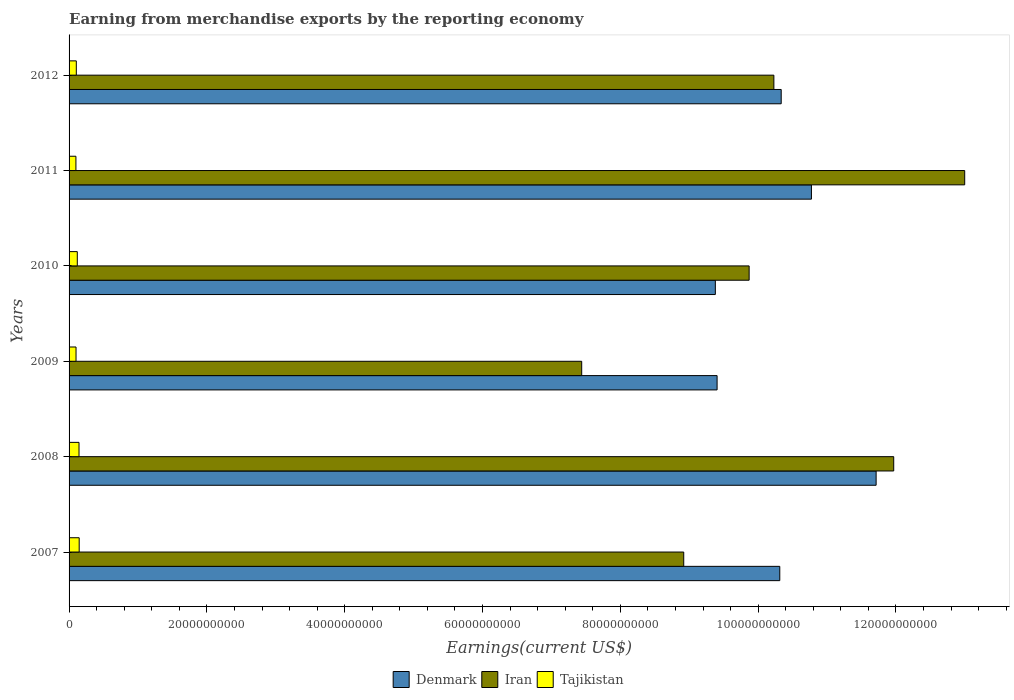How many different coloured bars are there?
Make the answer very short. 3. What is the label of the 5th group of bars from the top?
Offer a very short reply. 2008. What is the amount earned from merchandise exports in Iran in 2008?
Make the answer very short. 1.20e+11. Across all years, what is the maximum amount earned from merchandise exports in Denmark?
Provide a short and direct response. 1.17e+11. Across all years, what is the minimum amount earned from merchandise exports in Denmark?
Provide a succinct answer. 9.38e+1. In which year was the amount earned from merchandise exports in Tajikistan maximum?
Give a very brief answer. 2007. In which year was the amount earned from merchandise exports in Denmark minimum?
Give a very brief answer. 2010. What is the total amount earned from merchandise exports in Tajikistan in the graph?
Provide a succinct answer. 7.16e+09. What is the difference between the amount earned from merchandise exports in Denmark in 2008 and that in 2011?
Your answer should be very brief. 9.39e+09. What is the difference between the amount earned from merchandise exports in Tajikistan in 2011 and the amount earned from merchandise exports in Denmark in 2007?
Give a very brief answer. -1.02e+11. What is the average amount earned from merchandise exports in Iran per year?
Make the answer very short. 1.02e+11. In the year 2008, what is the difference between the amount earned from merchandise exports in Tajikistan and amount earned from merchandise exports in Iran?
Your answer should be compact. -1.18e+11. What is the ratio of the amount earned from merchandise exports in Denmark in 2007 to that in 2010?
Make the answer very short. 1.1. Is the difference between the amount earned from merchandise exports in Tajikistan in 2008 and 2011 greater than the difference between the amount earned from merchandise exports in Iran in 2008 and 2011?
Make the answer very short. Yes. What is the difference between the highest and the second highest amount earned from merchandise exports in Denmark?
Your answer should be compact. 9.39e+09. What is the difference between the highest and the lowest amount earned from merchandise exports in Iran?
Make the answer very short. 5.56e+1. In how many years, is the amount earned from merchandise exports in Iran greater than the average amount earned from merchandise exports in Iran taken over all years?
Provide a short and direct response. 2. Is the sum of the amount earned from merchandise exports in Iran in 2010 and 2012 greater than the maximum amount earned from merchandise exports in Denmark across all years?
Keep it short and to the point. Yes. What does the 2nd bar from the top in 2008 represents?
Your answer should be very brief. Iran. What does the 2nd bar from the bottom in 2008 represents?
Keep it short and to the point. Iran. How many bars are there?
Provide a short and direct response. 18. How many years are there in the graph?
Provide a succinct answer. 6. Does the graph contain any zero values?
Your answer should be compact. No. Does the graph contain grids?
Your answer should be compact. No. Where does the legend appear in the graph?
Give a very brief answer. Bottom center. How many legend labels are there?
Give a very brief answer. 3. What is the title of the graph?
Offer a very short reply. Earning from merchandise exports by the reporting economy. Does "World" appear as one of the legend labels in the graph?
Offer a terse response. No. What is the label or title of the X-axis?
Your response must be concise. Earnings(current US$). What is the Earnings(current US$) in Denmark in 2007?
Keep it short and to the point. 1.03e+11. What is the Earnings(current US$) of Iran in 2007?
Your answer should be compact. 8.92e+1. What is the Earnings(current US$) in Tajikistan in 2007?
Offer a very short reply. 1.47e+09. What is the Earnings(current US$) of Denmark in 2008?
Your answer should be compact. 1.17e+11. What is the Earnings(current US$) of Iran in 2008?
Provide a succinct answer. 1.20e+11. What is the Earnings(current US$) of Tajikistan in 2008?
Your response must be concise. 1.44e+09. What is the Earnings(current US$) of Denmark in 2009?
Your answer should be very brief. 9.40e+1. What is the Earnings(current US$) in Iran in 2009?
Ensure brevity in your answer.  7.44e+1. What is the Earnings(current US$) in Tajikistan in 2009?
Your response must be concise. 1.01e+09. What is the Earnings(current US$) in Denmark in 2010?
Provide a short and direct response. 9.38e+1. What is the Earnings(current US$) of Iran in 2010?
Ensure brevity in your answer.  9.87e+1. What is the Earnings(current US$) of Tajikistan in 2010?
Offer a very short reply. 1.19e+09. What is the Earnings(current US$) of Denmark in 2011?
Keep it short and to the point. 1.08e+11. What is the Earnings(current US$) in Iran in 2011?
Provide a short and direct response. 1.30e+11. What is the Earnings(current US$) in Tajikistan in 2011?
Provide a succinct answer. 9.94e+08. What is the Earnings(current US$) of Denmark in 2012?
Offer a very short reply. 1.03e+11. What is the Earnings(current US$) of Iran in 2012?
Your answer should be very brief. 1.02e+11. What is the Earnings(current US$) of Tajikistan in 2012?
Your answer should be very brief. 1.05e+09. Across all years, what is the maximum Earnings(current US$) in Denmark?
Offer a very short reply. 1.17e+11. Across all years, what is the maximum Earnings(current US$) in Iran?
Ensure brevity in your answer.  1.30e+11. Across all years, what is the maximum Earnings(current US$) in Tajikistan?
Offer a very short reply. 1.47e+09. Across all years, what is the minimum Earnings(current US$) in Denmark?
Provide a short and direct response. 9.38e+1. Across all years, what is the minimum Earnings(current US$) of Iran?
Offer a terse response. 7.44e+1. Across all years, what is the minimum Earnings(current US$) in Tajikistan?
Make the answer very short. 9.94e+08. What is the total Earnings(current US$) in Denmark in the graph?
Your response must be concise. 6.19e+11. What is the total Earnings(current US$) of Iran in the graph?
Provide a succinct answer. 6.14e+11. What is the total Earnings(current US$) of Tajikistan in the graph?
Your answer should be very brief. 7.16e+09. What is the difference between the Earnings(current US$) of Denmark in 2007 and that in 2008?
Ensure brevity in your answer.  -1.40e+1. What is the difference between the Earnings(current US$) in Iran in 2007 and that in 2008?
Offer a very short reply. -3.05e+1. What is the difference between the Earnings(current US$) in Tajikistan in 2007 and that in 2008?
Ensure brevity in your answer.  2.43e+07. What is the difference between the Earnings(current US$) in Denmark in 2007 and that in 2009?
Make the answer very short. 9.10e+09. What is the difference between the Earnings(current US$) in Iran in 2007 and that in 2009?
Keep it short and to the point. 1.48e+1. What is the difference between the Earnings(current US$) in Tajikistan in 2007 and that in 2009?
Keep it short and to the point. 4.58e+08. What is the difference between the Earnings(current US$) in Denmark in 2007 and that in 2010?
Ensure brevity in your answer.  9.35e+09. What is the difference between the Earnings(current US$) in Iran in 2007 and that in 2010?
Give a very brief answer. -9.49e+09. What is the difference between the Earnings(current US$) of Tajikistan in 2007 and that in 2010?
Your response must be concise. 2.73e+08. What is the difference between the Earnings(current US$) in Denmark in 2007 and that in 2011?
Ensure brevity in your answer.  -4.59e+09. What is the difference between the Earnings(current US$) of Iran in 2007 and that in 2011?
Offer a very short reply. -4.08e+1. What is the difference between the Earnings(current US$) in Tajikistan in 2007 and that in 2011?
Ensure brevity in your answer.  4.74e+08. What is the difference between the Earnings(current US$) of Denmark in 2007 and that in 2012?
Provide a succinct answer. -2.05e+08. What is the difference between the Earnings(current US$) of Iran in 2007 and that in 2012?
Provide a short and direct response. -1.31e+1. What is the difference between the Earnings(current US$) of Tajikistan in 2007 and that in 2012?
Your answer should be compact. 4.18e+08. What is the difference between the Earnings(current US$) of Denmark in 2008 and that in 2009?
Give a very brief answer. 2.31e+1. What is the difference between the Earnings(current US$) of Iran in 2008 and that in 2009?
Offer a very short reply. 4.53e+1. What is the difference between the Earnings(current US$) of Tajikistan in 2008 and that in 2009?
Give a very brief answer. 4.34e+08. What is the difference between the Earnings(current US$) in Denmark in 2008 and that in 2010?
Your response must be concise. 2.33e+1. What is the difference between the Earnings(current US$) in Iran in 2008 and that in 2010?
Keep it short and to the point. 2.10e+1. What is the difference between the Earnings(current US$) in Tajikistan in 2008 and that in 2010?
Offer a terse response. 2.49e+08. What is the difference between the Earnings(current US$) of Denmark in 2008 and that in 2011?
Your answer should be very brief. 9.39e+09. What is the difference between the Earnings(current US$) in Iran in 2008 and that in 2011?
Ensure brevity in your answer.  -1.03e+1. What is the difference between the Earnings(current US$) of Tajikistan in 2008 and that in 2011?
Your answer should be very brief. 4.50e+08. What is the difference between the Earnings(current US$) in Denmark in 2008 and that in 2012?
Provide a succinct answer. 1.38e+1. What is the difference between the Earnings(current US$) of Iran in 2008 and that in 2012?
Make the answer very short. 1.74e+1. What is the difference between the Earnings(current US$) in Tajikistan in 2008 and that in 2012?
Your answer should be very brief. 3.94e+08. What is the difference between the Earnings(current US$) in Denmark in 2009 and that in 2010?
Your answer should be compact. 2.54e+08. What is the difference between the Earnings(current US$) in Iran in 2009 and that in 2010?
Provide a short and direct response. -2.43e+1. What is the difference between the Earnings(current US$) in Tajikistan in 2009 and that in 2010?
Your answer should be very brief. -1.85e+08. What is the difference between the Earnings(current US$) in Denmark in 2009 and that in 2011?
Give a very brief answer. -1.37e+1. What is the difference between the Earnings(current US$) of Iran in 2009 and that in 2011?
Provide a succinct answer. -5.56e+1. What is the difference between the Earnings(current US$) in Tajikistan in 2009 and that in 2011?
Keep it short and to the point. 1.56e+07. What is the difference between the Earnings(current US$) of Denmark in 2009 and that in 2012?
Provide a short and direct response. -9.30e+09. What is the difference between the Earnings(current US$) in Iran in 2009 and that in 2012?
Keep it short and to the point. -2.79e+1. What is the difference between the Earnings(current US$) of Tajikistan in 2009 and that in 2012?
Provide a succinct answer. -4.05e+07. What is the difference between the Earnings(current US$) of Denmark in 2010 and that in 2011?
Provide a short and direct response. -1.39e+1. What is the difference between the Earnings(current US$) of Iran in 2010 and that in 2011?
Your answer should be very brief. -3.13e+1. What is the difference between the Earnings(current US$) in Tajikistan in 2010 and that in 2011?
Your response must be concise. 2.01e+08. What is the difference between the Earnings(current US$) of Denmark in 2010 and that in 2012?
Ensure brevity in your answer.  -9.56e+09. What is the difference between the Earnings(current US$) in Iran in 2010 and that in 2012?
Ensure brevity in your answer.  -3.59e+09. What is the difference between the Earnings(current US$) of Tajikistan in 2010 and that in 2012?
Make the answer very short. 1.45e+08. What is the difference between the Earnings(current US$) in Denmark in 2011 and that in 2012?
Your response must be concise. 4.39e+09. What is the difference between the Earnings(current US$) in Iran in 2011 and that in 2012?
Provide a succinct answer. 2.77e+1. What is the difference between the Earnings(current US$) of Tajikistan in 2011 and that in 2012?
Provide a succinct answer. -5.61e+07. What is the difference between the Earnings(current US$) of Denmark in 2007 and the Earnings(current US$) of Iran in 2008?
Your answer should be very brief. -1.65e+1. What is the difference between the Earnings(current US$) of Denmark in 2007 and the Earnings(current US$) of Tajikistan in 2008?
Give a very brief answer. 1.02e+11. What is the difference between the Earnings(current US$) in Iran in 2007 and the Earnings(current US$) in Tajikistan in 2008?
Offer a terse response. 8.78e+1. What is the difference between the Earnings(current US$) in Denmark in 2007 and the Earnings(current US$) in Iran in 2009?
Your response must be concise. 2.87e+1. What is the difference between the Earnings(current US$) of Denmark in 2007 and the Earnings(current US$) of Tajikistan in 2009?
Provide a succinct answer. 1.02e+11. What is the difference between the Earnings(current US$) of Iran in 2007 and the Earnings(current US$) of Tajikistan in 2009?
Your response must be concise. 8.82e+1. What is the difference between the Earnings(current US$) of Denmark in 2007 and the Earnings(current US$) of Iran in 2010?
Give a very brief answer. 4.45e+09. What is the difference between the Earnings(current US$) of Denmark in 2007 and the Earnings(current US$) of Tajikistan in 2010?
Offer a very short reply. 1.02e+11. What is the difference between the Earnings(current US$) of Iran in 2007 and the Earnings(current US$) of Tajikistan in 2010?
Your answer should be compact. 8.80e+1. What is the difference between the Earnings(current US$) in Denmark in 2007 and the Earnings(current US$) in Iran in 2011?
Offer a very short reply. -2.68e+1. What is the difference between the Earnings(current US$) of Denmark in 2007 and the Earnings(current US$) of Tajikistan in 2011?
Make the answer very short. 1.02e+11. What is the difference between the Earnings(current US$) of Iran in 2007 and the Earnings(current US$) of Tajikistan in 2011?
Provide a succinct answer. 8.82e+1. What is the difference between the Earnings(current US$) of Denmark in 2007 and the Earnings(current US$) of Iran in 2012?
Provide a succinct answer. 8.58e+08. What is the difference between the Earnings(current US$) in Denmark in 2007 and the Earnings(current US$) in Tajikistan in 2012?
Offer a very short reply. 1.02e+11. What is the difference between the Earnings(current US$) in Iran in 2007 and the Earnings(current US$) in Tajikistan in 2012?
Ensure brevity in your answer.  8.81e+1. What is the difference between the Earnings(current US$) of Denmark in 2008 and the Earnings(current US$) of Iran in 2009?
Give a very brief answer. 4.27e+1. What is the difference between the Earnings(current US$) of Denmark in 2008 and the Earnings(current US$) of Tajikistan in 2009?
Your answer should be compact. 1.16e+11. What is the difference between the Earnings(current US$) of Iran in 2008 and the Earnings(current US$) of Tajikistan in 2009?
Make the answer very short. 1.19e+11. What is the difference between the Earnings(current US$) in Denmark in 2008 and the Earnings(current US$) in Iran in 2010?
Your response must be concise. 1.84e+1. What is the difference between the Earnings(current US$) of Denmark in 2008 and the Earnings(current US$) of Tajikistan in 2010?
Your answer should be very brief. 1.16e+11. What is the difference between the Earnings(current US$) of Iran in 2008 and the Earnings(current US$) of Tajikistan in 2010?
Provide a succinct answer. 1.18e+11. What is the difference between the Earnings(current US$) in Denmark in 2008 and the Earnings(current US$) in Iran in 2011?
Your response must be concise. -1.29e+1. What is the difference between the Earnings(current US$) in Denmark in 2008 and the Earnings(current US$) in Tajikistan in 2011?
Offer a very short reply. 1.16e+11. What is the difference between the Earnings(current US$) in Iran in 2008 and the Earnings(current US$) in Tajikistan in 2011?
Your answer should be compact. 1.19e+11. What is the difference between the Earnings(current US$) in Denmark in 2008 and the Earnings(current US$) in Iran in 2012?
Keep it short and to the point. 1.48e+1. What is the difference between the Earnings(current US$) of Denmark in 2008 and the Earnings(current US$) of Tajikistan in 2012?
Offer a terse response. 1.16e+11. What is the difference between the Earnings(current US$) of Iran in 2008 and the Earnings(current US$) of Tajikistan in 2012?
Ensure brevity in your answer.  1.19e+11. What is the difference between the Earnings(current US$) of Denmark in 2009 and the Earnings(current US$) of Iran in 2010?
Your response must be concise. -4.65e+09. What is the difference between the Earnings(current US$) in Denmark in 2009 and the Earnings(current US$) in Tajikistan in 2010?
Provide a succinct answer. 9.28e+1. What is the difference between the Earnings(current US$) in Iran in 2009 and the Earnings(current US$) in Tajikistan in 2010?
Offer a very short reply. 7.32e+1. What is the difference between the Earnings(current US$) in Denmark in 2009 and the Earnings(current US$) in Iran in 2011?
Your answer should be compact. -3.59e+1. What is the difference between the Earnings(current US$) of Denmark in 2009 and the Earnings(current US$) of Tajikistan in 2011?
Provide a short and direct response. 9.30e+1. What is the difference between the Earnings(current US$) of Iran in 2009 and the Earnings(current US$) of Tajikistan in 2011?
Keep it short and to the point. 7.34e+1. What is the difference between the Earnings(current US$) in Denmark in 2009 and the Earnings(current US$) in Iran in 2012?
Your response must be concise. -8.24e+09. What is the difference between the Earnings(current US$) in Denmark in 2009 and the Earnings(current US$) in Tajikistan in 2012?
Give a very brief answer. 9.30e+1. What is the difference between the Earnings(current US$) of Iran in 2009 and the Earnings(current US$) of Tajikistan in 2012?
Keep it short and to the point. 7.33e+1. What is the difference between the Earnings(current US$) in Denmark in 2010 and the Earnings(current US$) in Iran in 2011?
Make the answer very short. -3.62e+1. What is the difference between the Earnings(current US$) of Denmark in 2010 and the Earnings(current US$) of Tajikistan in 2011?
Make the answer very short. 9.28e+1. What is the difference between the Earnings(current US$) in Iran in 2010 and the Earnings(current US$) in Tajikistan in 2011?
Ensure brevity in your answer.  9.77e+1. What is the difference between the Earnings(current US$) of Denmark in 2010 and the Earnings(current US$) of Iran in 2012?
Provide a succinct answer. -8.49e+09. What is the difference between the Earnings(current US$) of Denmark in 2010 and the Earnings(current US$) of Tajikistan in 2012?
Your answer should be compact. 9.27e+1. What is the difference between the Earnings(current US$) of Iran in 2010 and the Earnings(current US$) of Tajikistan in 2012?
Offer a terse response. 9.76e+1. What is the difference between the Earnings(current US$) of Denmark in 2011 and the Earnings(current US$) of Iran in 2012?
Your answer should be compact. 5.45e+09. What is the difference between the Earnings(current US$) in Denmark in 2011 and the Earnings(current US$) in Tajikistan in 2012?
Make the answer very short. 1.07e+11. What is the difference between the Earnings(current US$) of Iran in 2011 and the Earnings(current US$) of Tajikistan in 2012?
Ensure brevity in your answer.  1.29e+11. What is the average Earnings(current US$) of Denmark per year?
Make the answer very short. 1.03e+11. What is the average Earnings(current US$) of Iran per year?
Make the answer very short. 1.02e+11. What is the average Earnings(current US$) of Tajikistan per year?
Offer a very short reply. 1.19e+09. In the year 2007, what is the difference between the Earnings(current US$) of Denmark and Earnings(current US$) of Iran?
Offer a terse response. 1.39e+1. In the year 2007, what is the difference between the Earnings(current US$) in Denmark and Earnings(current US$) in Tajikistan?
Offer a terse response. 1.02e+11. In the year 2007, what is the difference between the Earnings(current US$) of Iran and Earnings(current US$) of Tajikistan?
Your response must be concise. 8.77e+1. In the year 2008, what is the difference between the Earnings(current US$) in Denmark and Earnings(current US$) in Iran?
Offer a very short reply. -2.55e+09. In the year 2008, what is the difference between the Earnings(current US$) in Denmark and Earnings(current US$) in Tajikistan?
Provide a succinct answer. 1.16e+11. In the year 2008, what is the difference between the Earnings(current US$) of Iran and Earnings(current US$) of Tajikistan?
Give a very brief answer. 1.18e+11. In the year 2009, what is the difference between the Earnings(current US$) of Denmark and Earnings(current US$) of Iran?
Provide a short and direct response. 1.96e+1. In the year 2009, what is the difference between the Earnings(current US$) in Denmark and Earnings(current US$) in Tajikistan?
Your answer should be very brief. 9.30e+1. In the year 2009, what is the difference between the Earnings(current US$) of Iran and Earnings(current US$) of Tajikistan?
Your answer should be compact. 7.34e+1. In the year 2010, what is the difference between the Earnings(current US$) of Denmark and Earnings(current US$) of Iran?
Give a very brief answer. -4.91e+09. In the year 2010, what is the difference between the Earnings(current US$) of Denmark and Earnings(current US$) of Tajikistan?
Provide a short and direct response. 9.26e+1. In the year 2010, what is the difference between the Earnings(current US$) of Iran and Earnings(current US$) of Tajikistan?
Your answer should be compact. 9.75e+1. In the year 2011, what is the difference between the Earnings(current US$) of Denmark and Earnings(current US$) of Iran?
Your answer should be very brief. -2.22e+1. In the year 2011, what is the difference between the Earnings(current US$) of Denmark and Earnings(current US$) of Tajikistan?
Your response must be concise. 1.07e+11. In the year 2011, what is the difference between the Earnings(current US$) of Iran and Earnings(current US$) of Tajikistan?
Your response must be concise. 1.29e+11. In the year 2012, what is the difference between the Earnings(current US$) of Denmark and Earnings(current US$) of Iran?
Provide a succinct answer. 1.06e+09. In the year 2012, what is the difference between the Earnings(current US$) in Denmark and Earnings(current US$) in Tajikistan?
Ensure brevity in your answer.  1.02e+11. In the year 2012, what is the difference between the Earnings(current US$) of Iran and Earnings(current US$) of Tajikistan?
Provide a short and direct response. 1.01e+11. What is the ratio of the Earnings(current US$) of Denmark in 2007 to that in 2008?
Offer a terse response. 0.88. What is the ratio of the Earnings(current US$) in Iran in 2007 to that in 2008?
Offer a very short reply. 0.75. What is the ratio of the Earnings(current US$) of Tajikistan in 2007 to that in 2008?
Provide a short and direct response. 1.02. What is the ratio of the Earnings(current US$) of Denmark in 2007 to that in 2009?
Provide a succinct answer. 1.1. What is the ratio of the Earnings(current US$) of Iran in 2007 to that in 2009?
Give a very brief answer. 1.2. What is the ratio of the Earnings(current US$) in Tajikistan in 2007 to that in 2009?
Make the answer very short. 1.45. What is the ratio of the Earnings(current US$) in Denmark in 2007 to that in 2010?
Keep it short and to the point. 1.1. What is the ratio of the Earnings(current US$) in Iran in 2007 to that in 2010?
Keep it short and to the point. 0.9. What is the ratio of the Earnings(current US$) of Tajikistan in 2007 to that in 2010?
Your response must be concise. 1.23. What is the ratio of the Earnings(current US$) in Denmark in 2007 to that in 2011?
Your answer should be very brief. 0.96. What is the ratio of the Earnings(current US$) of Iran in 2007 to that in 2011?
Your answer should be compact. 0.69. What is the ratio of the Earnings(current US$) of Tajikistan in 2007 to that in 2011?
Provide a short and direct response. 1.48. What is the ratio of the Earnings(current US$) of Denmark in 2007 to that in 2012?
Your answer should be compact. 1. What is the ratio of the Earnings(current US$) of Iran in 2007 to that in 2012?
Make the answer very short. 0.87. What is the ratio of the Earnings(current US$) of Tajikistan in 2007 to that in 2012?
Offer a very short reply. 1.4. What is the ratio of the Earnings(current US$) of Denmark in 2008 to that in 2009?
Ensure brevity in your answer.  1.25. What is the ratio of the Earnings(current US$) in Iran in 2008 to that in 2009?
Give a very brief answer. 1.61. What is the ratio of the Earnings(current US$) of Tajikistan in 2008 to that in 2009?
Provide a short and direct response. 1.43. What is the ratio of the Earnings(current US$) of Denmark in 2008 to that in 2010?
Make the answer very short. 1.25. What is the ratio of the Earnings(current US$) of Iran in 2008 to that in 2010?
Offer a terse response. 1.21. What is the ratio of the Earnings(current US$) in Tajikistan in 2008 to that in 2010?
Your response must be concise. 1.21. What is the ratio of the Earnings(current US$) of Denmark in 2008 to that in 2011?
Give a very brief answer. 1.09. What is the ratio of the Earnings(current US$) of Iran in 2008 to that in 2011?
Your answer should be very brief. 0.92. What is the ratio of the Earnings(current US$) in Tajikistan in 2008 to that in 2011?
Ensure brevity in your answer.  1.45. What is the ratio of the Earnings(current US$) in Denmark in 2008 to that in 2012?
Ensure brevity in your answer.  1.13. What is the ratio of the Earnings(current US$) of Iran in 2008 to that in 2012?
Make the answer very short. 1.17. What is the ratio of the Earnings(current US$) in Tajikistan in 2008 to that in 2012?
Your answer should be very brief. 1.37. What is the ratio of the Earnings(current US$) of Iran in 2009 to that in 2010?
Offer a terse response. 0.75. What is the ratio of the Earnings(current US$) of Tajikistan in 2009 to that in 2010?
Give a very brief answer. 0.85. What is the ratio of the Earnings(current US$) of Denmark in 2009 to that in 2011?
Give a very brief answer. 0.87. What is the ratio of the Earnings(current US$) of Iran in 2009 to that in 2011?
Ensure brevity in your answer.  0.57. What is the ratio of the Earnings(current US$) in Tajikistan in 2009 to that in 2011?
Provide a succinct answer. 1.02. What is the ratio of the Earnings(current US$) of Denmark in 2009 to that in 2012?
Your answer should be very brief. 0.91. What is the ratio of the Earnings(current US$) of Iran in 2009 to that in 2012?
Offer a terse response. 0.73. What is the ratio of the Earnings(current US$) of Tajikistan in 2009 to that in 2012?
Provide a short and direct response. 0.96. What is the ratio of the Earnings(current US$) in Denmark in 2010 to that in 2011?
Your answer should be compact. 0.87. What is the ratio of the Earnings(current US$) of Iran in 2010 to that in 2011?
Your response must be concise. 0.76. What is the ratio of the Earnings(current US$) of Tajikistan in 2010 to that in 2011?
Offer a terse response. 1.2. What is the ratio of the Earnings(current US$) of Denmark in 2010 to that in 2012?
Ensure brevity in your answer.  0.91. What is the ratio of the Earnings(current US$) of Iran in 2010 to that in 2012?
Provide a short and direct response. 0.96. What is the ratio of the Earnings(current US$) in Tajikistan in 2010 to that in 2012?
Provide a short and direct response. 1.14. What is the ratio of the Earnings(current US$) of Denmark in 2011 to that in 2012?
Offer a very short reply. 1.04. What is the ratio of the Earnings(current US$) of Iran in 2011 to that in 2012?
Offer a very short reply. 1.27. What is the ratio of the Earnings(current US$) of Tajikistan in 2011 to that in 2012?
Make the answer very short. 0.95. What is the difference between the highest and the second highest Earnings(current US$) of Denmark?
Make the answer very short. 9.39e+09. What is the difference between the highest and the second highest Earnings(current US$) in Iran?
Provide a short and direct response. 1.03e+1. What is the difference between the highest and the second highest Earnings(current US$) of Tajikistan?
Ensure brevity in your answer.  2.43e+07. What is the difference between the highest and the lowest Earnings(current US$) in Denmark?
Keep it short and to the point. 2.33e+1. What is the difference between the highest and the lowest Earnings(current US$) of Iran?
Offer a very short reply. 5.56e+1. What is the difference between the highest and the lowest Earnings(current US$) of Tajikistan?
Offer a terse response. 4.74e+08. 